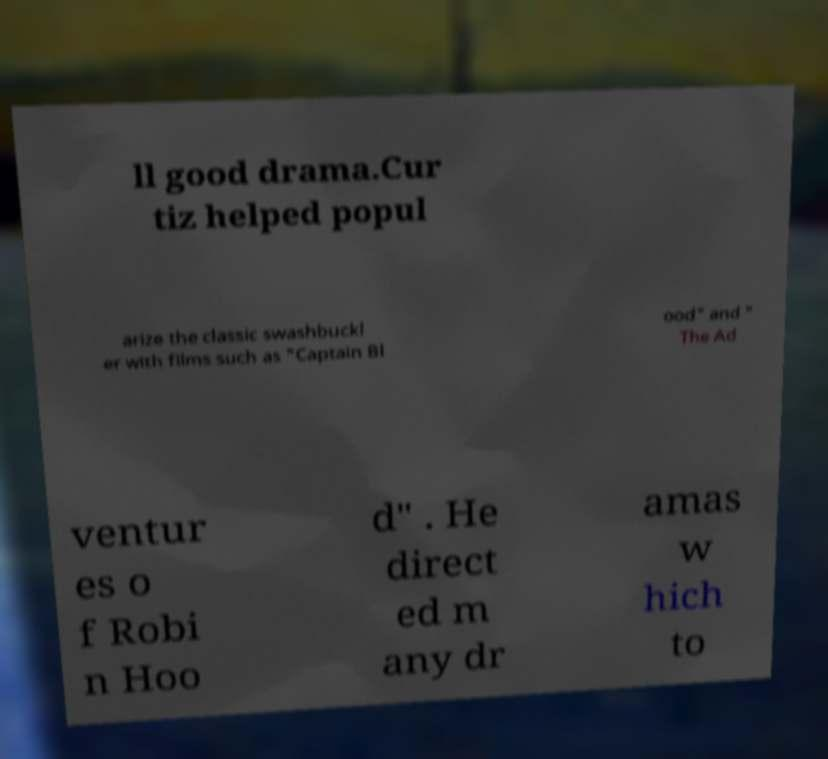Could you extract and type out the text from this image? ll good drama.Cur tiz helped popul arize the classic swashbuckl er with films such as "Captain Bl ood" and " The Ad ventur es o f Robi n Hoo d" . He direct ed m any dr amas w hich to 